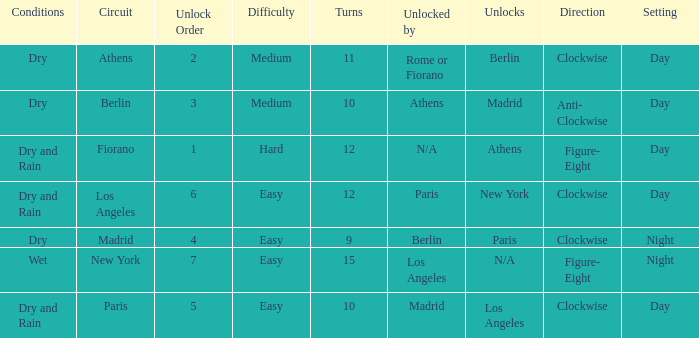What are the conditions for the athens circuit? Dry. 